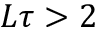Convert formula to latex. <formula><loc_0><loc_0><loc_500><loc_500>L \tau > 2</formula> 